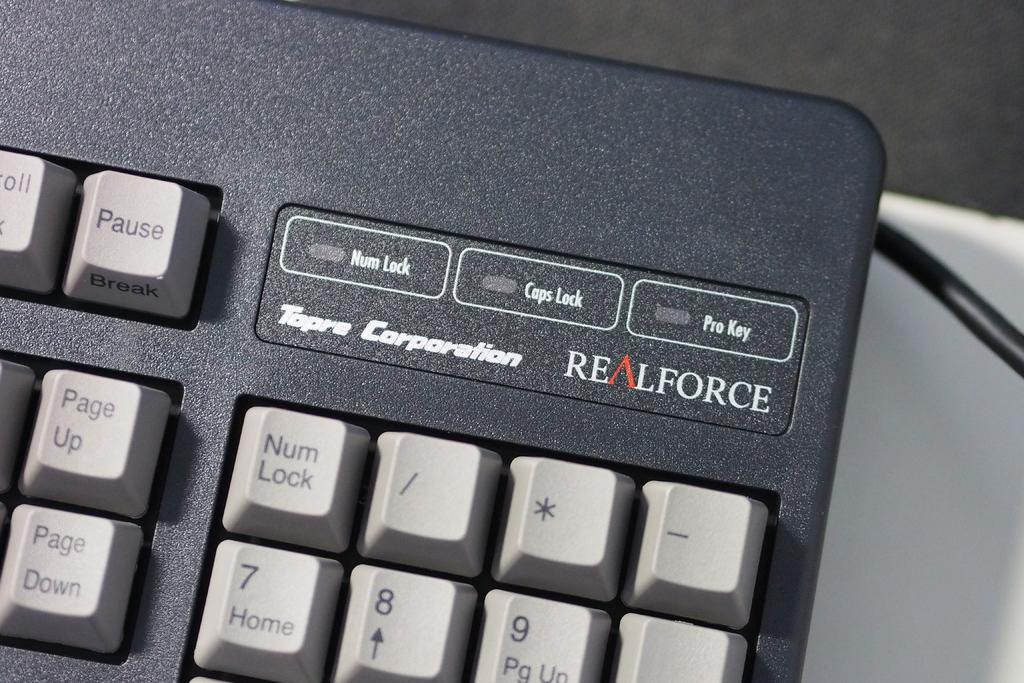<image>
Describe the image concisely. A black and white realforce keyboard with keys. 